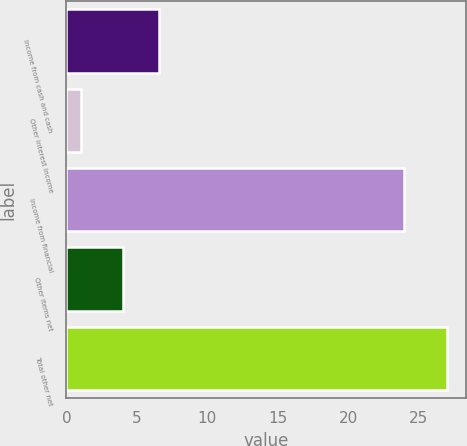<chart> <loc_0><loc_0><loc_500><loc_500><bar_chart><fcel>Income from cash and cash<fcel>Other interest income<fcel>Income from financial<fcel>Other items net<fcel>Total other net<nl><fcel>6.6<fcel>1<fcel>24<fcel>4<fcel>27<nl></chart> 